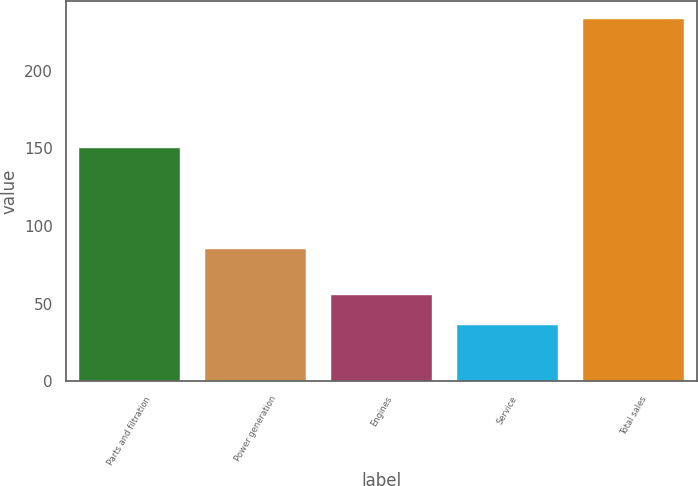Convert chart to OTSL. <chart><loc_0><loc_0><loc_500><loc_500><bar_chart><fcel>Parts and filtration<fcel>Power generation<fcel>Engines<fcel>Service<fcel>Total sales<nl><fcel>150<fcel>85<fcel>55.7<fcel>36<fcel>233<nl></chart> 